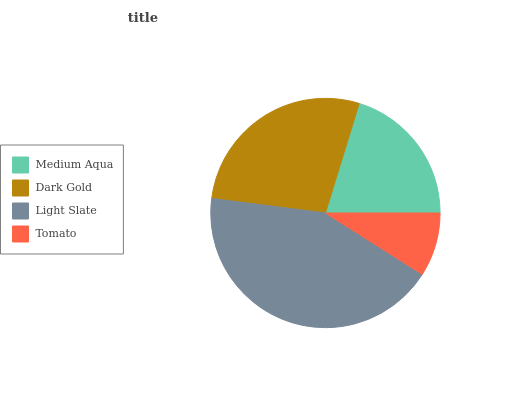Is Tomato the minimum?
Answer yes or no. Yes. Is Light Slate the maximum?
Answer yes or no. Yes. Is Dark Gold the minimum?
Answer yes or no. No. Is Dark Gold the maximum?
Answer yes or no. No. Is Dark Gold greater than Medium Aqua?
Answer yes or no. Yes. Is Medium Aqua less than Dark Gold?
Answer yes or no. Yes. Is Medium Aqua greater than Dark Gold?
Answer yes or no. No. Is Dark Gold less than Medium Aqua?
Answer yes or no. No. Is Dark Gold the high median?
Answer yes or no. Yes. Is Medium Aqua the low median?
Answer yes or no. Yes. Is Light Slate the high median?
Answer yes or no. No. Is Dark Gold the low median?
Answer yes or no. No. 